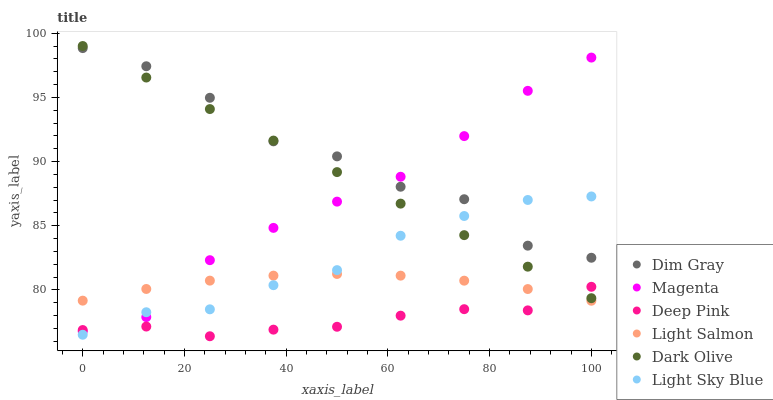Does Deep Pink have the minimum area under the curve?
Answer yes or no. Yes. Does Dim Gray have the maximum area under the curve?
Answer yes or no. Yes. Does Dark Olive have the minimum area under the curve?
Answer yes or no. No. Does Dark Olive have the maximum area under the curve?
Answer yes or no. No. Is Dark Olive the smoothest?
Answer yes or no. Yes. Is Dim Gray the roughest?
Answer yes or no. Yes. Is Dim Gray the smoothest?
Answer yes or no. No. Is Dark Olive the roughest?
Answer yes or no. No. Does Deep Pink have the lowest value?
Answer yes or no. Yes. Does Dark Olive have the lowest value?
Answer yes or no. No. Does Dark Olive have the highest value?
Answer yes or no. Yes. Does Dim Gray have the highest value?
Answer yes or no. No. Is Light Salmon less than Dim Gray?
Answer yes or no. Yes. Is Dark Olive greater than Light Salmon?
Answer yes or no. Yes. Does Dim Gray intersect Magenta?
Answer yes or no. Yes. Is Dim Gray less than Magenta?
Answer yes or no. No. Is Dim Gray greater than Magenta?
Answer yes or no. No. Does Light Salmon intersect Dim Gray?
Answer yes or no. No. 